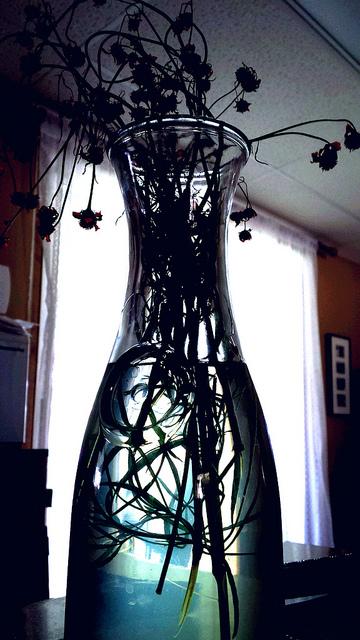What is behind the vase?
Short answer required. Window. Is there water in the vase?
Answer briefly. Yes. What color are the curtains?
Be succinct. White. 